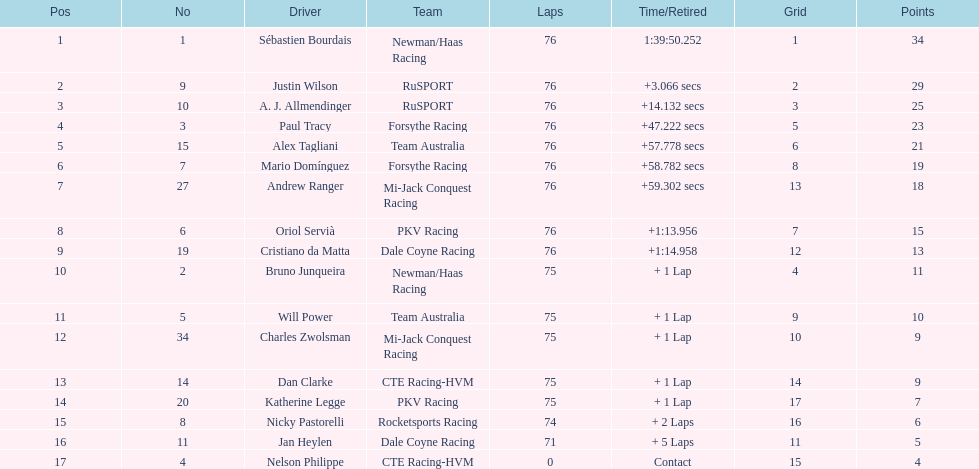Charles zwolsman acquired the same number of points as who? Dan Clarke. 